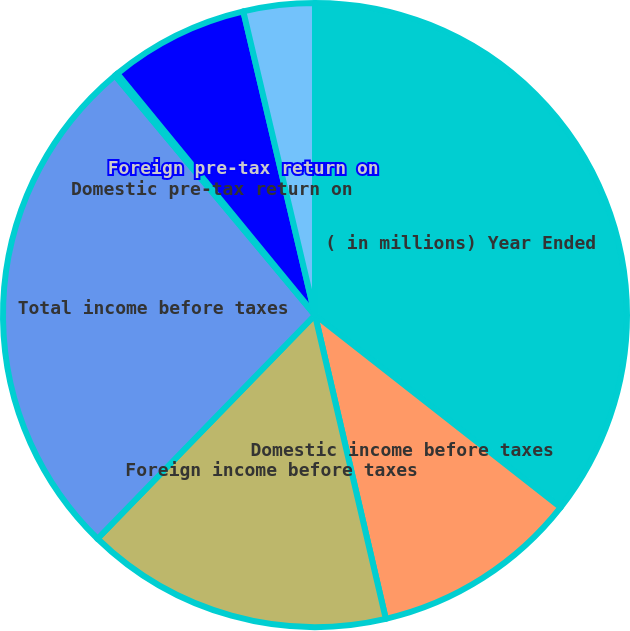Convert chart to OTSL. <chart><loc_0><loc_0><loc_500><loc_500><pie_chart><fcel>( in millions) Year Ended<fcel>Domestic income before taxes<fcel>Foreign income before taxes<fcel>Total income before taxes<fcel>Domestic pre-tax return on<fcel>Foreign pre-tax return on<fcel>Total pre-tax return on<nl><fcel>35.58%<fcel>10.78%<fcel>15.92%<fcel>26.66%<fcel>0.15%<fcel>7.23%<fcel>3.69%<nl></chart> 